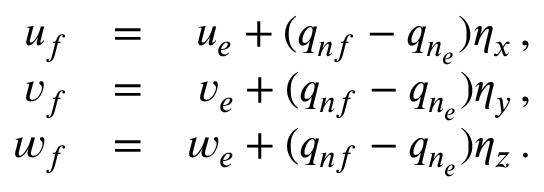Convert formula to latex. <formula><loc_0><loc_0><loc_500><loc_500>\begin{array} { r l r } { u _ { f } } & { = } & { u _ { e } + ( q _ { n f } - q _ { n _ { e } } ) \eta _ { x } \, , } \\ { v _ { f } } & { = } & { v _ { e } + ( q _ { n f } - q _ { n _ { e } } ) \eta _ { y } \, , } \\ { w _ { f } } & { = } & { w _ { e } + ( q _ { n f } - q _ { n _ { e } } ) \eta _ { z } \, . } \end{array}</formula> 